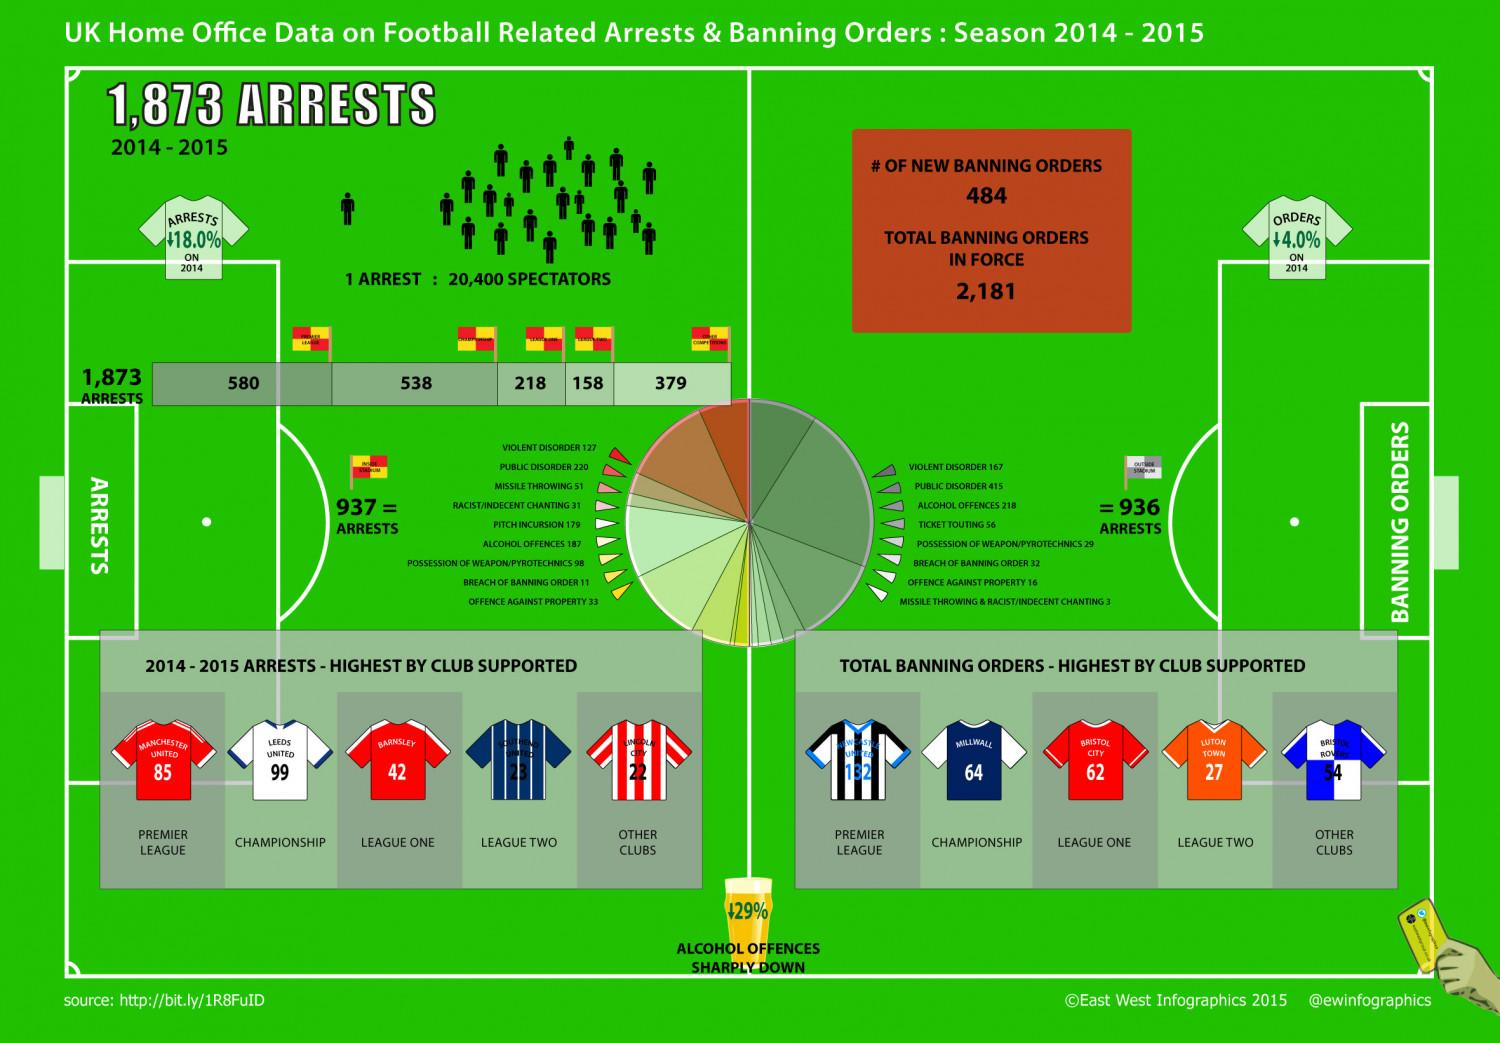Give some essential details in this illustration. During six matches in the Championship, a total of 64 banning orders were issued involving the football club Millwall. During the 2014-2015 football championship matches, Leeds United was involved in 99 football-related arrests. During the 2014-15 League One season, Bristol City was issued with 62 banning orders. Alcohol offenses have decreased by 29%. During the 2014-15 Premier League season, Manchester United was involved in 85 arrests. 